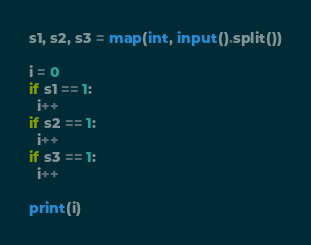Convert code to text. <code><loc_0><loc_0><loc_500><loc_500><_Python_>s1, s2, s3 = map(int, input().split())

i = 0
if s1 == 1:
  i++
if s2 == 1:
  i++
if s3 == 1:
  i++
  
print(i)</code> 